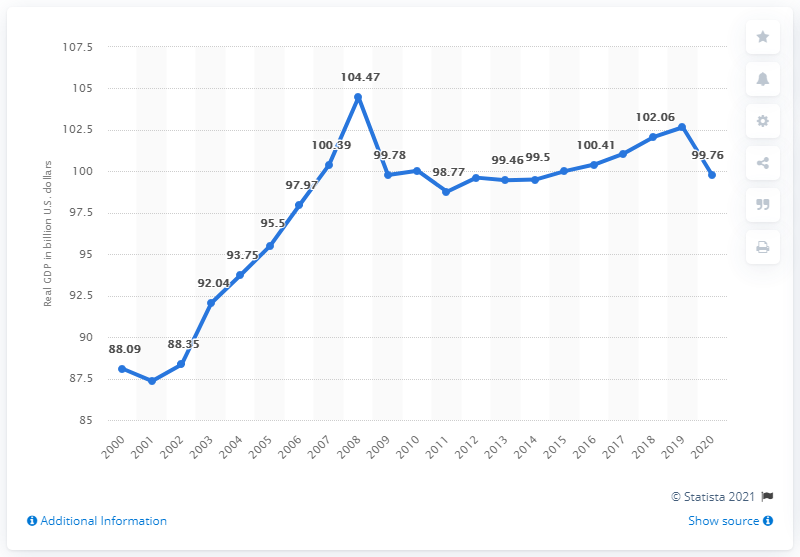Highlight a few significant elements in this photo. Mississippi's Gross Domestic Product (GDP) was valued at approximately 102.66 billion dollars in 2018. In 2020, Mississippi's Gross Domestic Product (GDP) was 99.76. 